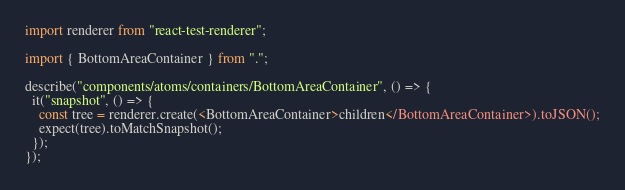Convert code to text. <code><loc_0><loc_0><loc_500><loc_500><_TypeScript_>import renderer from "react-test-renderer";

import { BottomAreaContainer } from ".";

describe("components/atoms/containers/BottomAreaContainer", () => {
  it("snapshot", () => {
    const tree = renderer.create(<BottomAreaContainer>children</BottomAreaContainer>).toJSON();
    expect(tree).toMatchSnapshot();
  });
});
</code> 